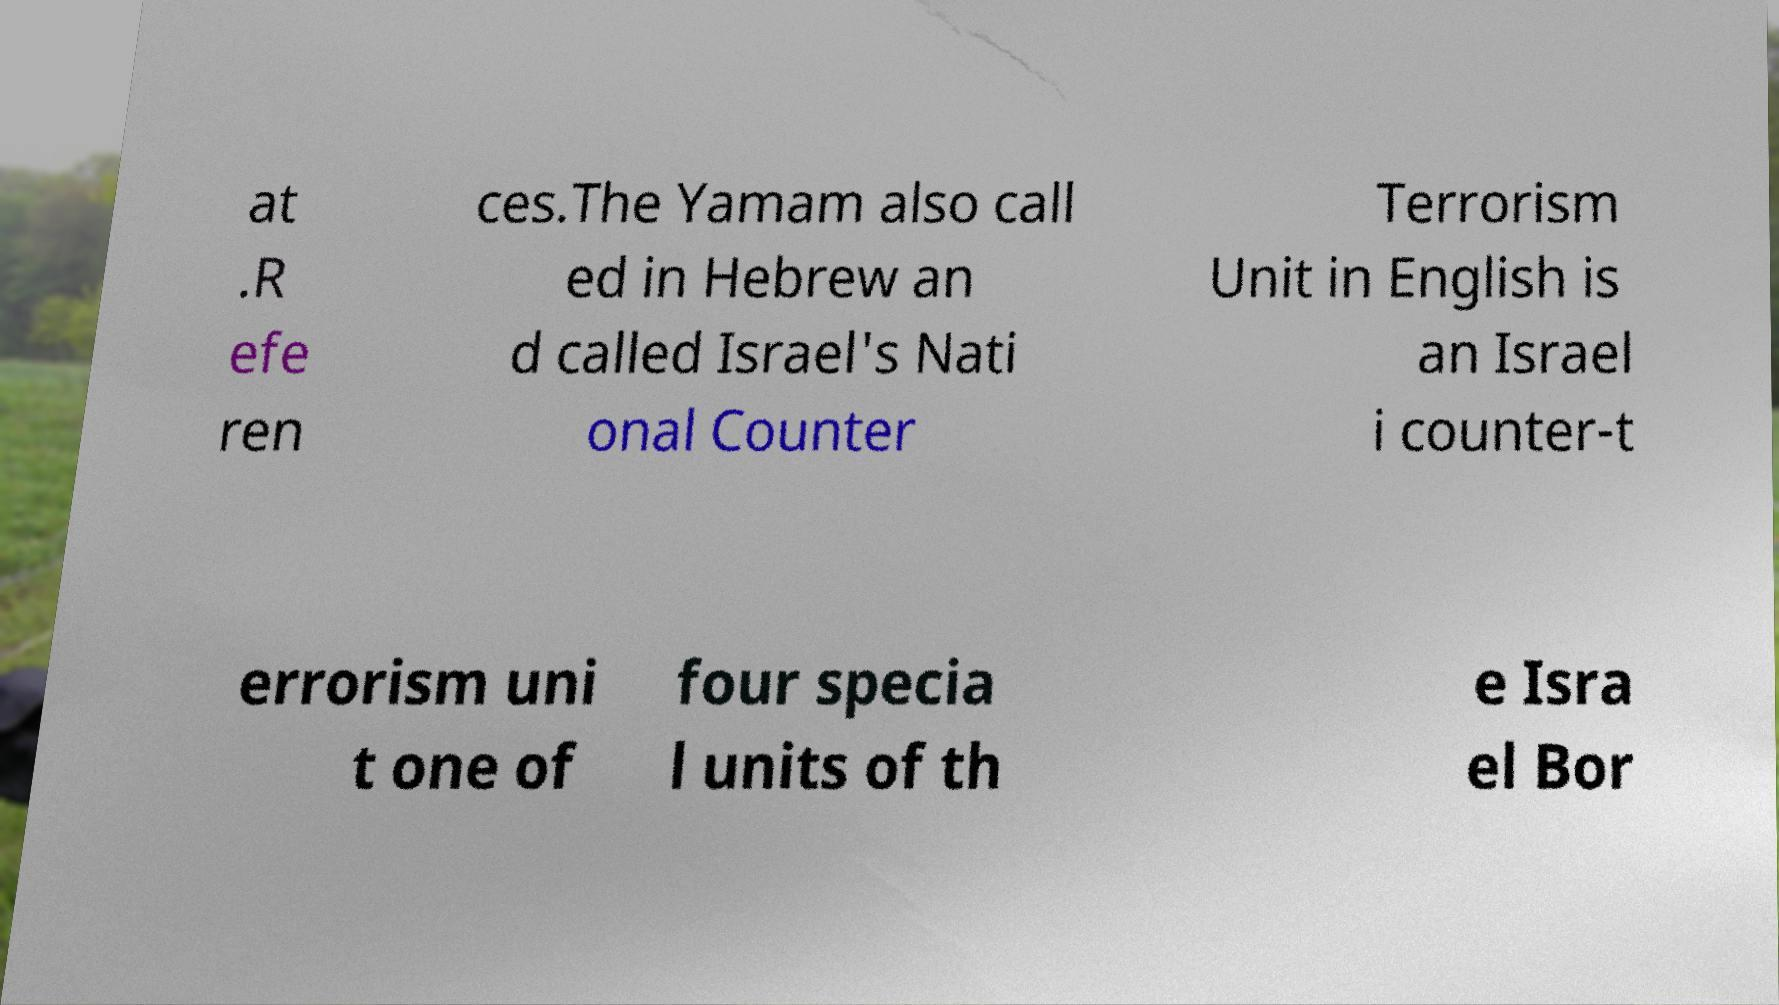For documentation purposes, I need the text within this image transcribed. Could you provide that? at .R efe ren ces.The Yamam also call ed in Hebrew an d called Israel's Nati onal Counter Terrorism Unit in English is an Israel i counter-t errorism uni t one of four specia l units of th e Isra el Bor 